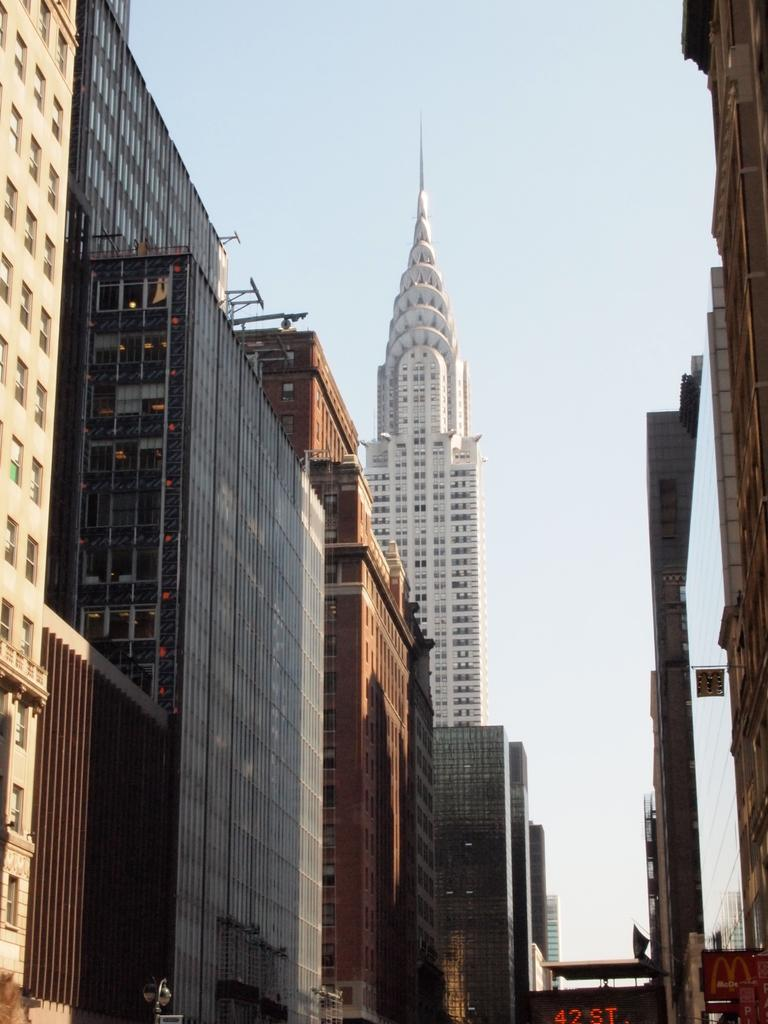What type of structures can be seen in the image? There are buildings in the image. What is visible in the background of the image? The sky is visible in the background of the image. How would you describe the sky in the image? The sky appears to be clear in the image. How many times does the skin appear in the image? There is no mention of skin in the image, so it cannot be determined how many times it appears. 